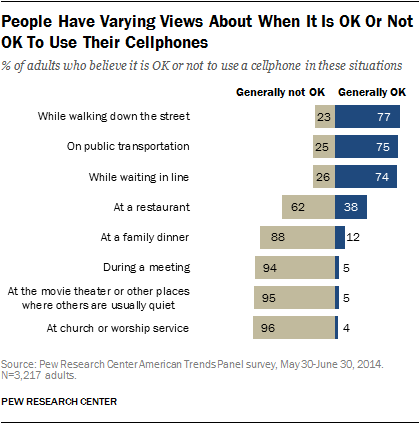Outline some significant characteristics in this image. The situation with the largest blue bar is one that occurs while walking down the street. The difference between the largest grey bar and the largest blue bar is 19. 